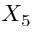<formula> <loc_0><loc_0><loc_500><loc_500>X _ { 5 }</formula> 